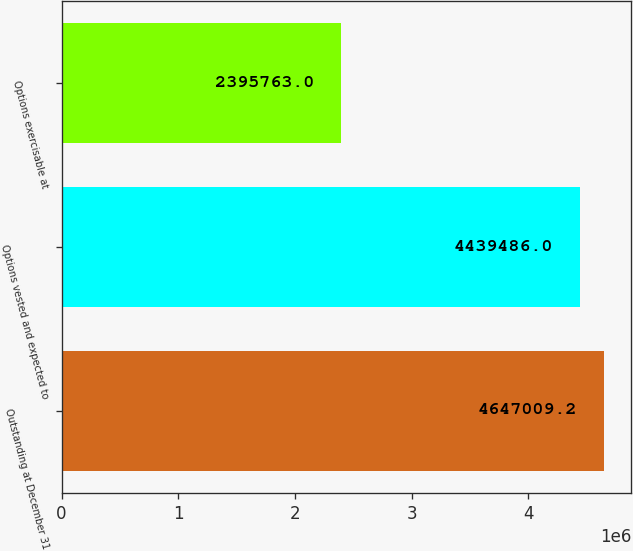<chart> <loc_0><loc_0><loc_500><loc_500><bar_chart><fcel>Outstanding at December 31<fcel>Options vested and expected to<fcel>Options exercisable at<nl><fcel>4.64701e+06<fcel>4.43949e+06<fcel>2.39576e+06<nl></chart> 